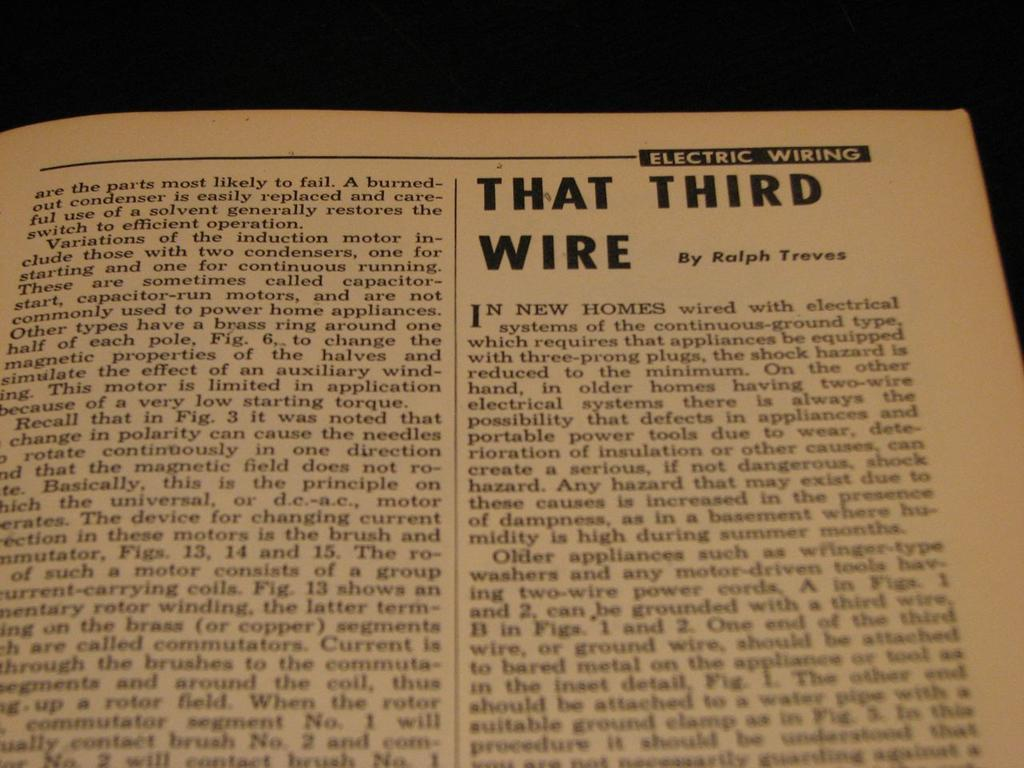Provide a one-sentence caption for the provided image. In the electric wiring manual, it talks about that third wire. 